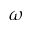<formula> <loc_0><loc_0><loc_500><loc_500>\omega</formula> 